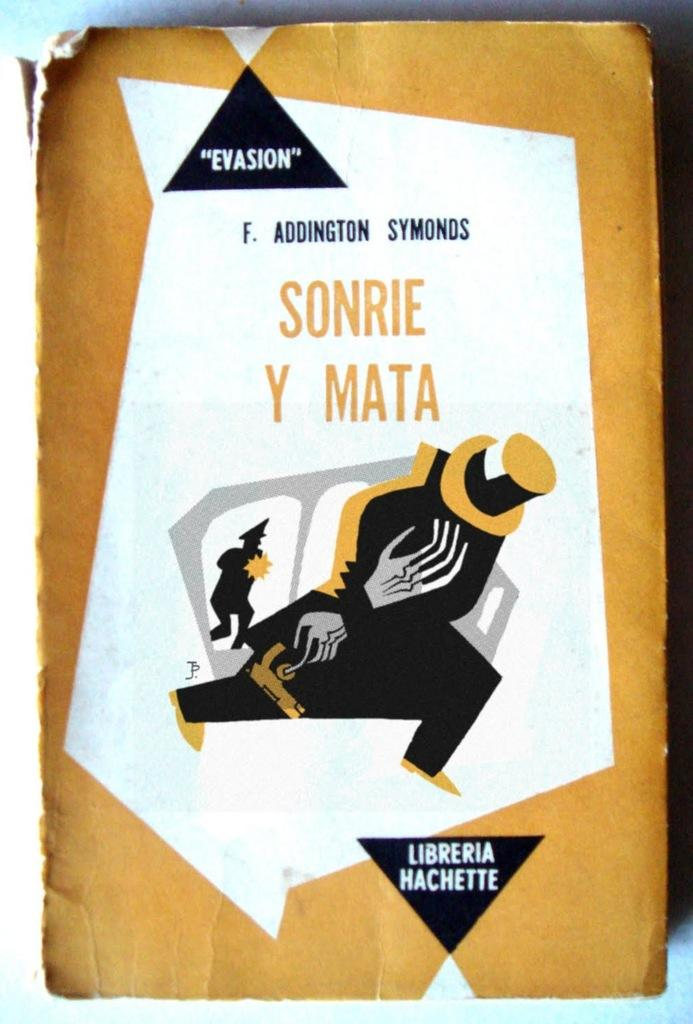<image>
Create a compact narrative representing the image presented. the word sonrie is on the white item 